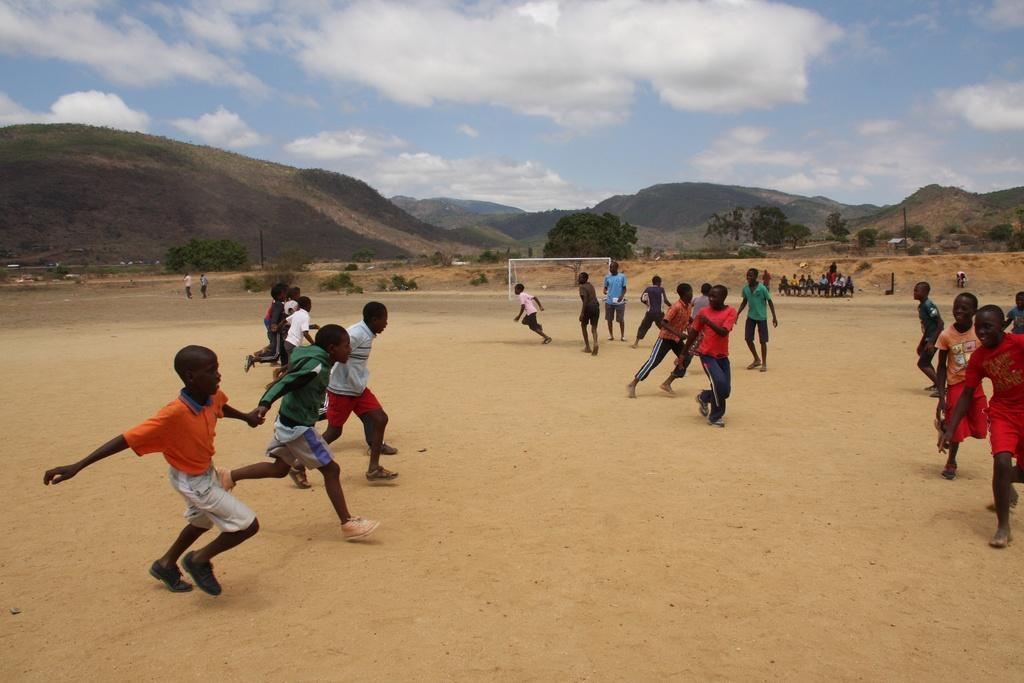Describe this image in one or two sentences. In this image, there are a few people. We can see the ground and some net. We can also see some plants, trees, hills. We can also see the sky with some clouds. 